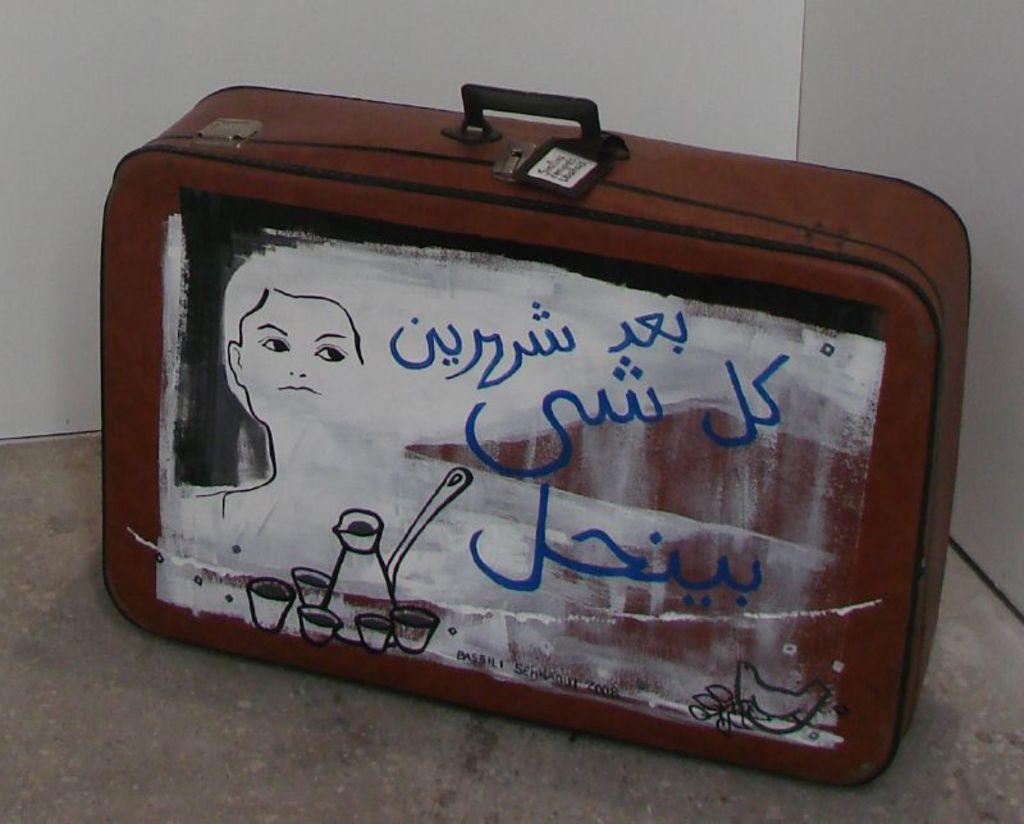What object can be seen in the image? There is a briefcase in the image. What is unique about the briefcase? The briefcase has some painting on it. Can you see a giraffe biting into a stick of butter in the image? No, there is no giraffe or butter present in the image. 